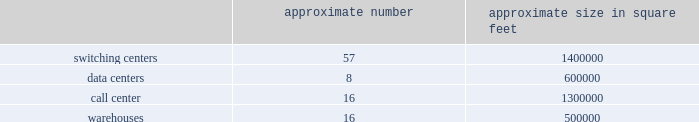Does not believe are in our and our stockholders 2019 best interest .
The rights plan is intended to protect stockholders in the event of an unfair or coercive offer to acquire the company and to provide our board of directors with adequate time to evaluate unsolicited offers .
The rights plan may prevent or make takeovers or unsolicited corporate transactions with respect to our company more difficult , even if stockholders may consider such transactions favorable , possibly including transactions in which stockholders might otherwise receive a premium for their shares .
Item 1b .
Unresolved staff comments item 2 .
Properties as of december 31 , 2016 , our significant properties used in connection with switching centers , data centers , call centers and warehouses were as follows: .
As of december 31 , 2016 , we leased approximately 60000 cell sites .
As of december 31 , 2016 , we leased approximately 2000 t-mobile and metropcs retail locations , including stores and kiosks ranging in size from approximately 100 square feet to 17000 square feet .
We currently lease office space totaling approximately 950000 square feet for our corporate headquarters in bellevue , washington .
We use these offices for engineering and administrative purposes .
We also lease space throughout the u.s. , totaling approximately 1200000 square feet as of december 31 , 2016 , for use by our regional offices primarily for administrative , engineering and sales purposes .
Item 3 .
Legal proceedings see note 12 2013 commitments and contingencies of the notes to the consolidated financial statements included in part ii , item 8 of this form 10-k for information regarding certain legal proceedings in which we are involved .
Item 4 .
Mine safety disclosures part ii .
Item 5 .
Market for registrant 2019s common equity , related stockholder matters and issuer purchases of equity securities market information our common stock is traded on the nasdaq global select market of the nasdaq stock market llc ( 201cnasdaq 201d ) under the symbol 201ctmus . 201d as of december 31 , 2016 , there were 309 registered stockholders of record of our common stock , but we estimate the total number of stockholders to be much higher as a number of our shares are held by brokers or dealers for their customers in street name. .
What is the average space of the warehouse in square feet? 
Rationale: the average space of a warehouse was 31250
Computations: (500000 / 16)
Answer: 31250.0. 